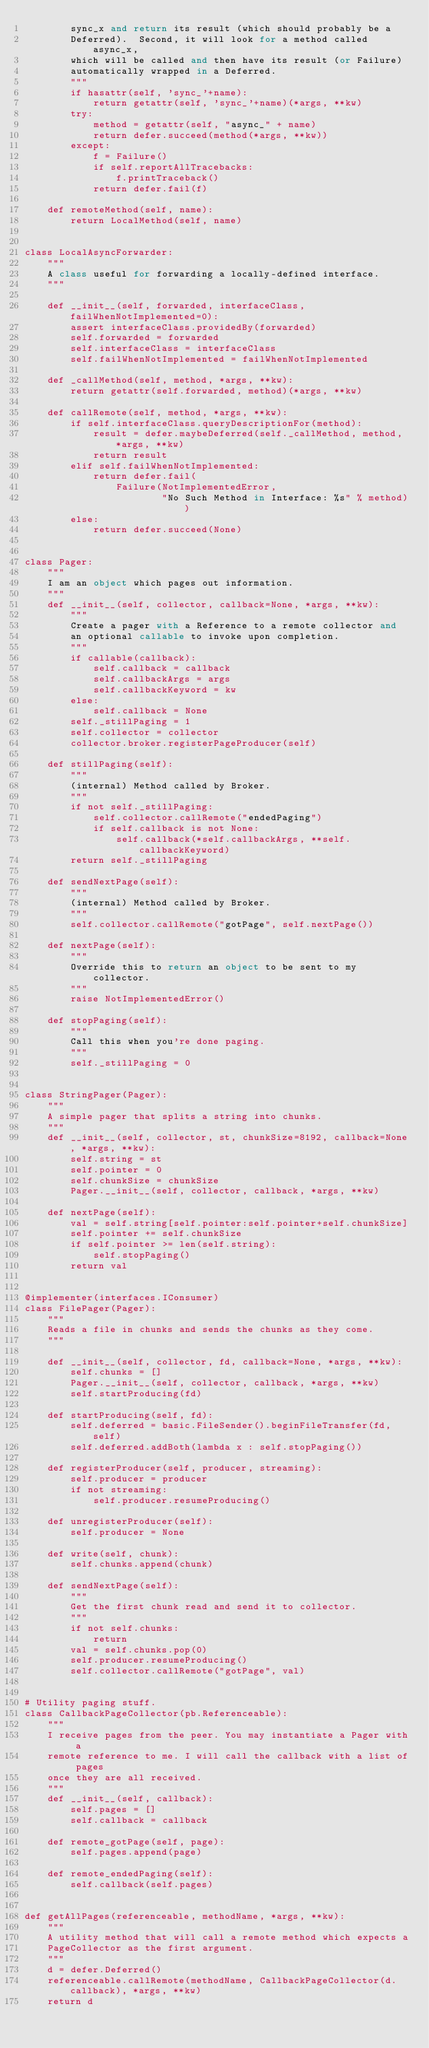<code> <loc_0><loc_0><loc_500><loc_500><_Python_>        sync_x and return its result (which should probably be a
        Deferred).  Second, it will look for a method called async_x,
        which will be called and then have its result (or Failure)
        automatically wrapped in a Deferred.
        """
        if hasattr(self, 'sync_'+name):
            return getattr(self, 'sync_'+name)(*args, **kw)
        try:
            method = getattr(self, "async_" + name)
            return defer.succeed(method(*args, **kw))
        except:
            f = Failure()
            if self.reportAllTracebacks:
                f.printTraceback()
            return defer.fail(f)

    def remoteMethod(self, name):
        return LocalMethod(self, name)


class LocalAsyncForwarder:
    """
    A class useful for forwarding a locally-defined interface.
    """

    def __init__(self, forwarded, interfaceClass, failWhenNotImplemented=0):
        assert interfaceClass.providedBy(forwarded)
        self.forwarded = forwarded
        self.interfaceClass = interfaceClass
        self.failWhenNotImplemented = failWhenNotImplemented

    def _callMethod(self, method, *args, **kw):
        return getattr(self.forwarded, method)(*args, **kw)

    def callRemote(self, method, *args, **kw):
        if self.interfaceClass.queryDescriptionFor(method):
            result = defer.maybeDeferred(self._callMethod, method, *args, **kw)
            return result
        elif self.failWhenNotImplemented:
            return defer.fail(
                Failure(NotImplementedError,
                        "No Such Method in Interface: %s" % method))
        else:
            return defer.succeed(None)


class Pager:
    """
    I am an object which pages out information.
    """
    def __init__(self, collector, callback=None, *args, **kw):
        """
        Create a pager with a Reference to a remote collector and
        an optional callable to invoke upon completion.
        """
        if callable(callback):
            self.callback = callback
            self.callbackArgs = args
            self.callbackKeyword = kw
        else:
            self.callback = None
        self._stillPaging = 1
        self.collector = collector
        collector.broker.registerPageProducer(self)

    def stillPaging(self):
        """
        (internal) Method called by Broker.
        """
        if not self._stillPaging:
            self.collector.callRemote("endedPaging")
            if self.callback is not None:
                self.callback(*self.callbackArgs, **self.callbackKeyword)
        return self._stillPaging

    def sendNextPage(self):
        """
        (internal) Method called by Broker.
        """
        self.collector.callRemote("gotPage", self.nextPage())

    def nextPage(self):
        """
        Override this to return an object to be sent to my collector.
        """
        raise NotImplementedError()

    def stopPaging(self):
        """
        Call this when you're done paging.
        """
        self._stillPaging = 0


class StringPager(Pager):
    """
    A simple pager that splits a string into chunks.
    """
    def __init__(self, collector, st, chunkSize=8192, callback=None, *args, **kw):
        self.string = st
        self.pointer = 0
        self.chunkSize = chunkSize
        Pager.__init__(self, collector, callback, *args, **kw)

    def nextPage(self):
        val = self.string[self.pointer:self.pointer+self.chunkSize]
        self.pointer += self.chunkSize
        if self.pointer >= len(self.string):
            self.stopPaging()
        return val


@implementer(interfaces.IConsumer)
class FilePager(Pager):
    """
    Reads a file in chunks and sends the chunks as they come.
    """

    def __init__(self, collector, fd, callback=None, *args, **kw):
        self.chunks = []
        Pager.__init__(self, collector, callback, *args, **kw)
        self.startProducing(fd)

    def startProducing(self, fd):
        self.deferred = basic.FileSender().beginFileTransfer(fd, self)
        self.deferred.addBoth(lambda x : self.stopPaging())

    def registerProducer(self, producer, streaming):
        self.producer = producer
        if not streaming:
            self.producer.resumeProducing()

    def unregisterProducer(self):
        self.producer = None

    def write(self, chunk):
        self.chunks.append(chunk)

    def sendNextPage(self):
        """
        Get the first chunk read and send it to collector.
        """
        if not self.chunks:
            return
        val = self.chunks.pop(0)
        self.producer.resumeProducing()
        self.collector.callRemote("gotPage", val)


# Utility paging stuff.
class CallbackPageCollector(pb.Referenceable):
    """
    I receive pages from the peer. You may instantiate a Pager with a
    remote reference to me. I will call the callback with a list of pages
    once they are all received.
    """
    def __init__(self, callback):
        self.pages = []
        self.callback = callback

    def remote_gotPage(self, page):
        self.pages.append(page)

    def remote_endedPaging(self):
        self.callback(self.pages)


def getAllPages(referenceable, methodName, *args, **kw):
    """
    A utility method that will call a remote method which expects a
    PageCollector as the first argument.
    """
    d = defer.Deferred()
    referenceable.callRemote(methodName, CallbackPageCollector(d.callback), *args, **kw)
    return d

</code> 